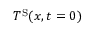<formula> <loc_0><loc_0><loc_500><loc_500>T ^ { S } ( x , t = 0 )</formula> 